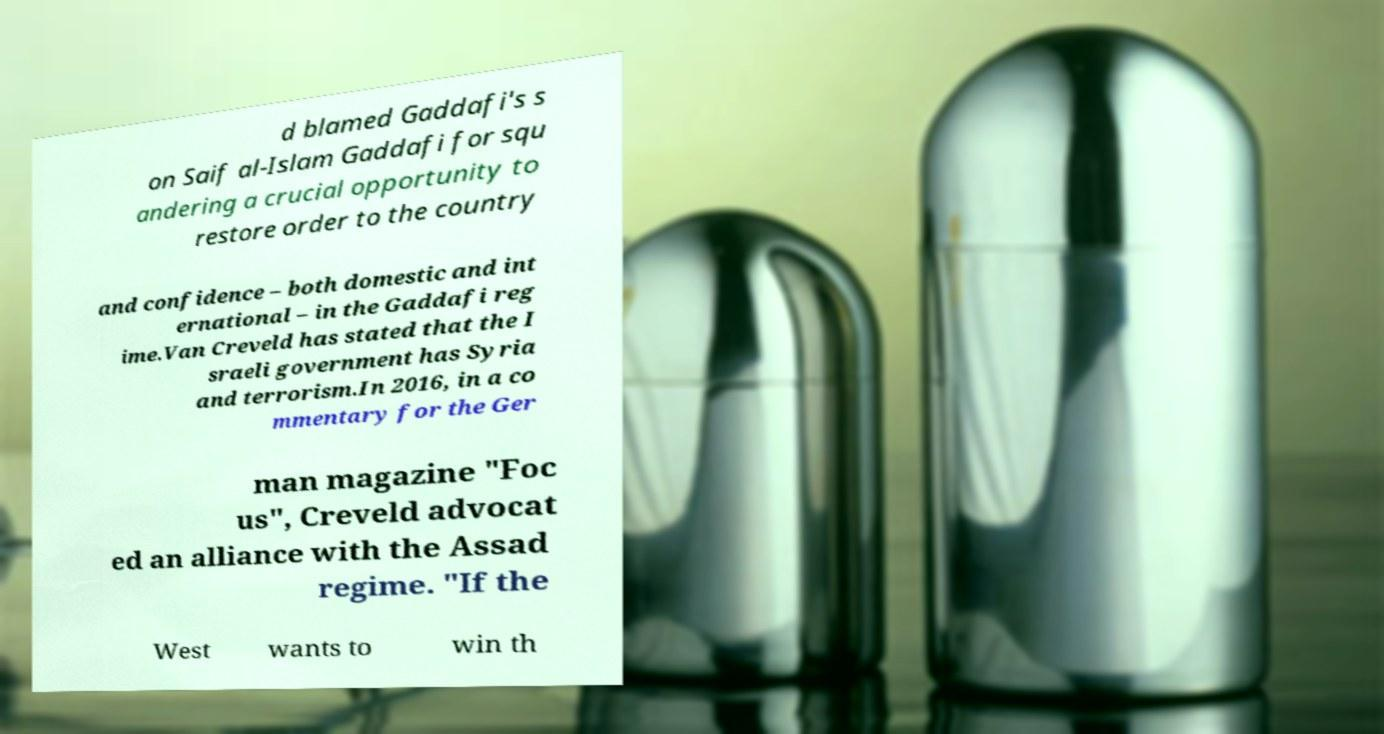Can you accurately transcribe the text from the provided image for me? d blamed Gaddafi's s on Saif al-Islam Gaddafi for squ andering a crucial opportunity to restore order to the country and confidence – both domestic and int ernational – in the Gaddafi reg ime.Van Creveld has stated that the I sraeli government has Syria and terrorism.In 2016, in a co mmentary for the Ger man magazine "Foc us", Creveld advocat ed an alliance with the Assad regime. "If the West wants to win th 